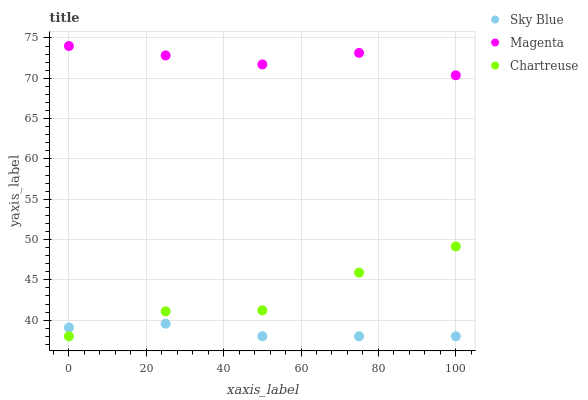Does Sky Blue have the minimum area under the curve?
Answer yes or no. Yes. Does Magenta have the maximum area under the curve?
Answer yes or no. Yes. Does Chartreuse have the minimum area under the curve?
Answer yes or no. No. Does Chartreuse have the maximum area under the curve?
Answer yes or no. No. Is Sky Blue the smoothest?
Answer yes or no. Yes. Is Chartreuse the roughest?
Answer yes or no. Yes. Is Magenta the smoothest?
Answer yes or no. No. Is Magenta the roughest?
Answer yes or no. No. Does Sky Blue have the lowest value?
Answer yes or no. Yes. Does Magenta have the lowest value?
Answer yes or no. No. Does Magenta have the highest value?
Answer yes or no. Yes. Does Chartreuse have the highest value?
Answer yes or no. No. Is Sky Blue less than Magenta?
Answer yes or no. Yes. Is Magenta greater than Chartreuse?
Answer yes or no. Yes. Does Sky Blue intersect Chartreuse?
Answer yes or no. Yes. Is Sky Blue less than Chartreuse?
Answer yes or no. No. Is Sky Blue greater than Chartreuse?
Answer yes or no. No. Does Sky Blue intersect Magenta?
Answer yes or no. No. 